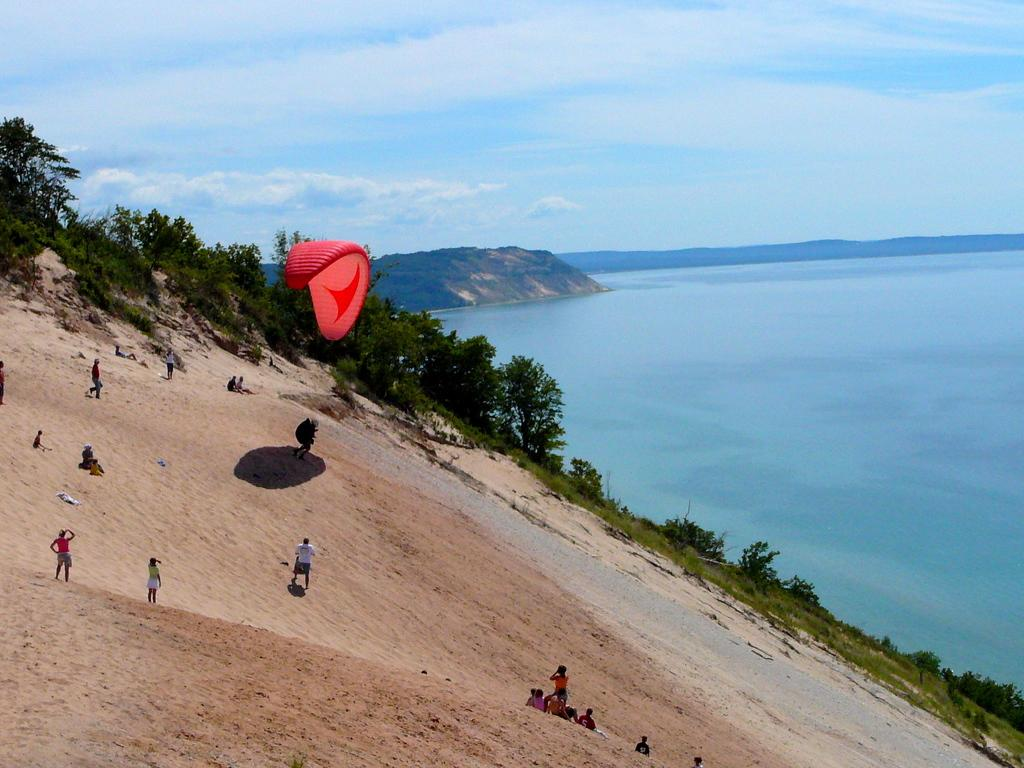What activity is the person on the left side of the image engaged in? The person on the left side of the image is paragliding. What are some people doing in the image? Some people are sitting and standing in the image. What can be seen in the background of the image? There is a sea, a hill, trees, and the sky visible in the background of the image. What type of robin is perched on the tent in the image? There is no robin or tent present in the image. What meal is being prepared in the image? There is no meal preparation visible in the image. 